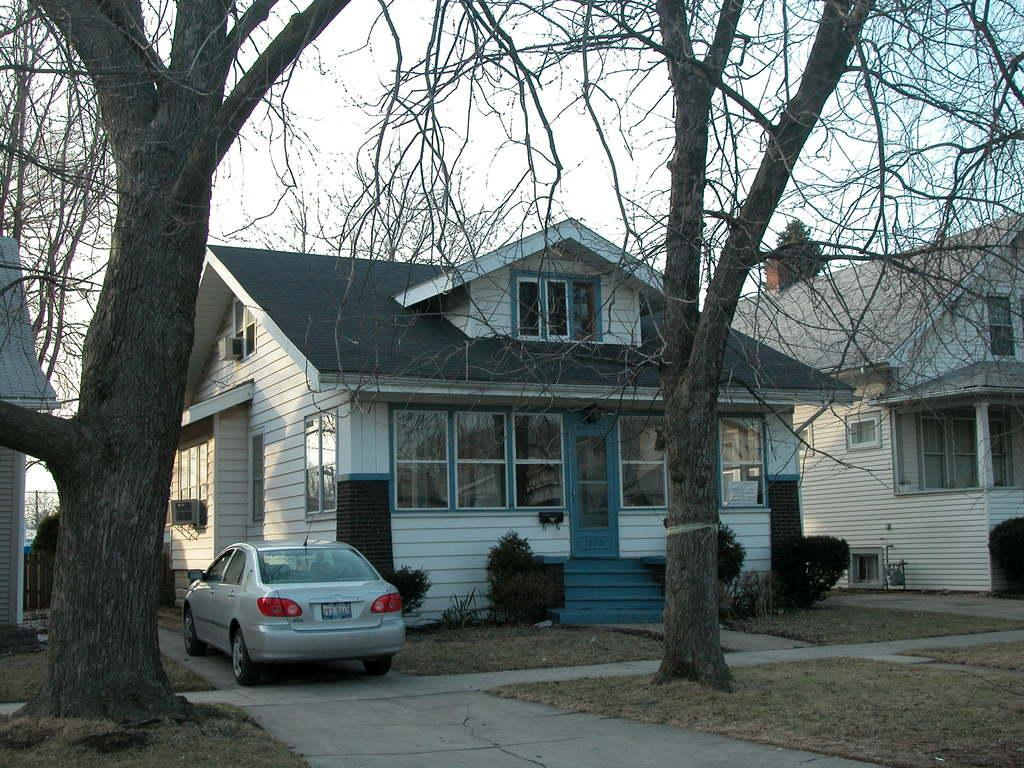What is blocking the path in the image? There is a car parked on the path in the image. What can be seen in the distance behind the car? There are group of buildings and trees in the background of the image. What is visible above the buildings and trees? The sky is visible in the background of the image. What type of furniture can be seen in the image? There is no furniture present in the image. Can you hear a robin whistling in the image? There is no sound, including a robin whistling, depicted in the image. 